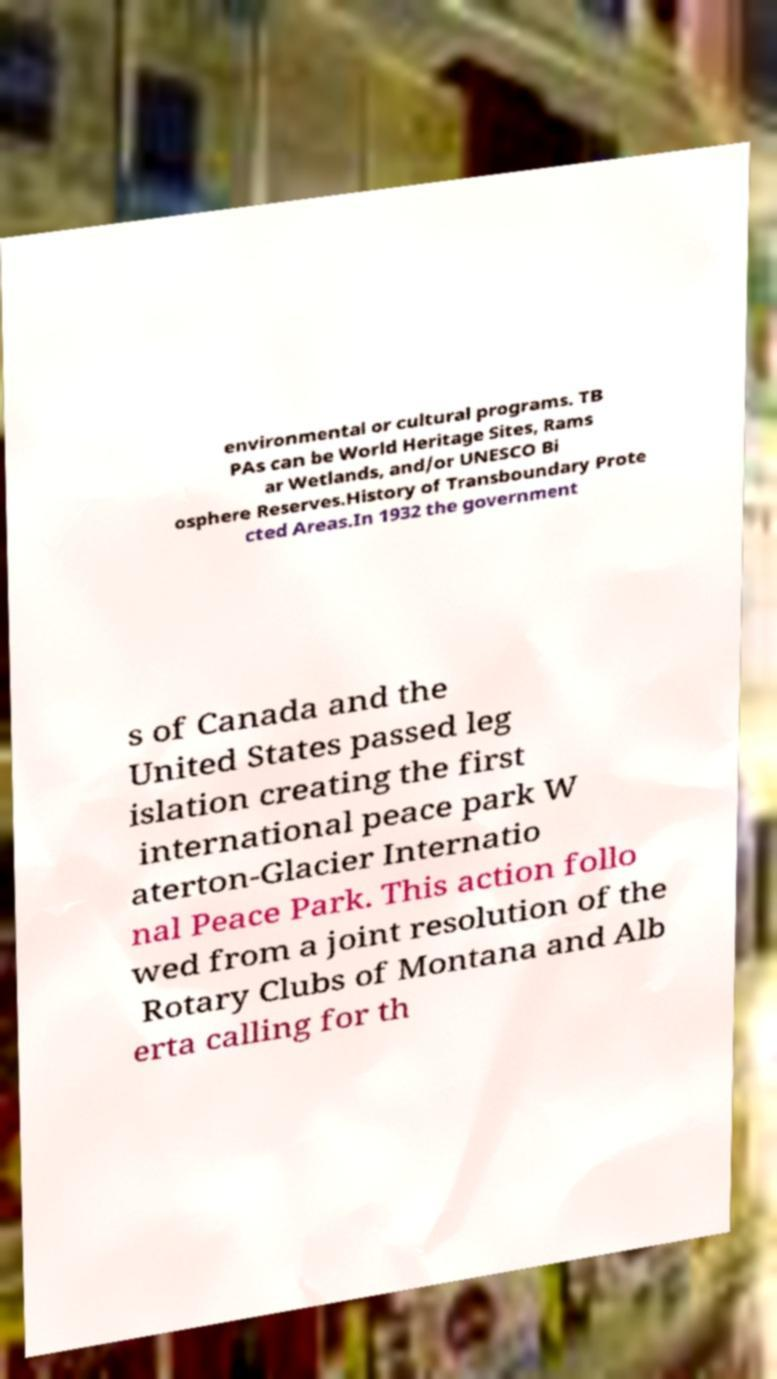Can you read and provide the text displayed in the image?This photo seems to have some interesting text. Can you extract and type it out for me? environmental or cultural programs. TB PAs can be World Heritage Sites, Rams ar Wetlands, and/or UNESCO Bi osphere Reserves.History of Transboundary Prote cted Areas.In 1932 the government s of Canada and the United States passed leg islation creating the first international peace park W aterton-Glacier Internatio nal Peace Park. This action follo wed from a joint resolution of the Rotary Clubs of Montana and Alb erta calling for th 